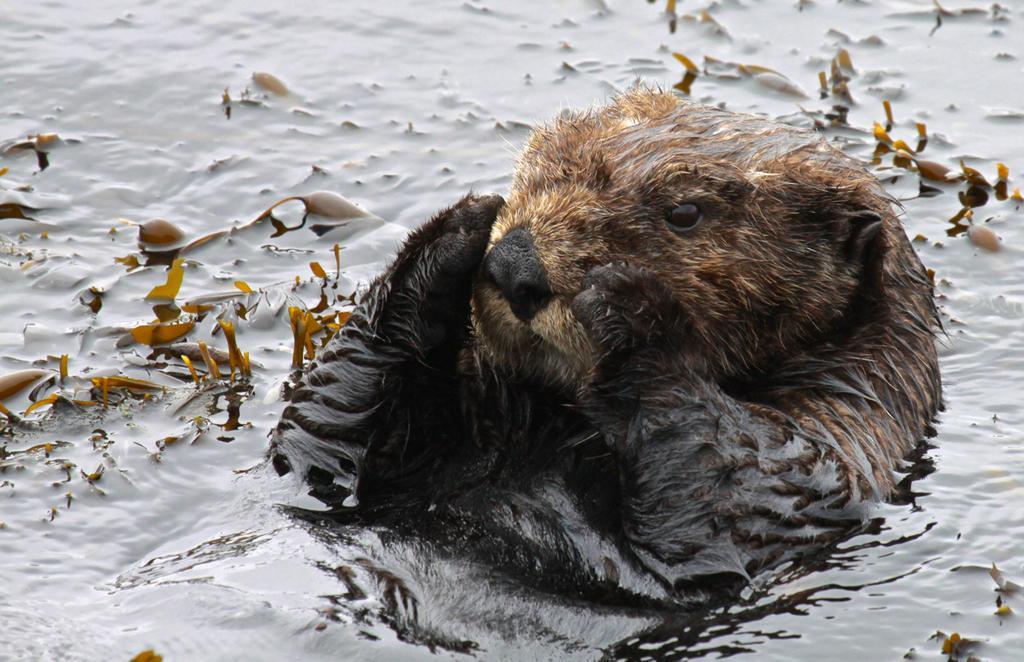Describe this image in one or two sentences. In this image I can see a sea otter in the water. 